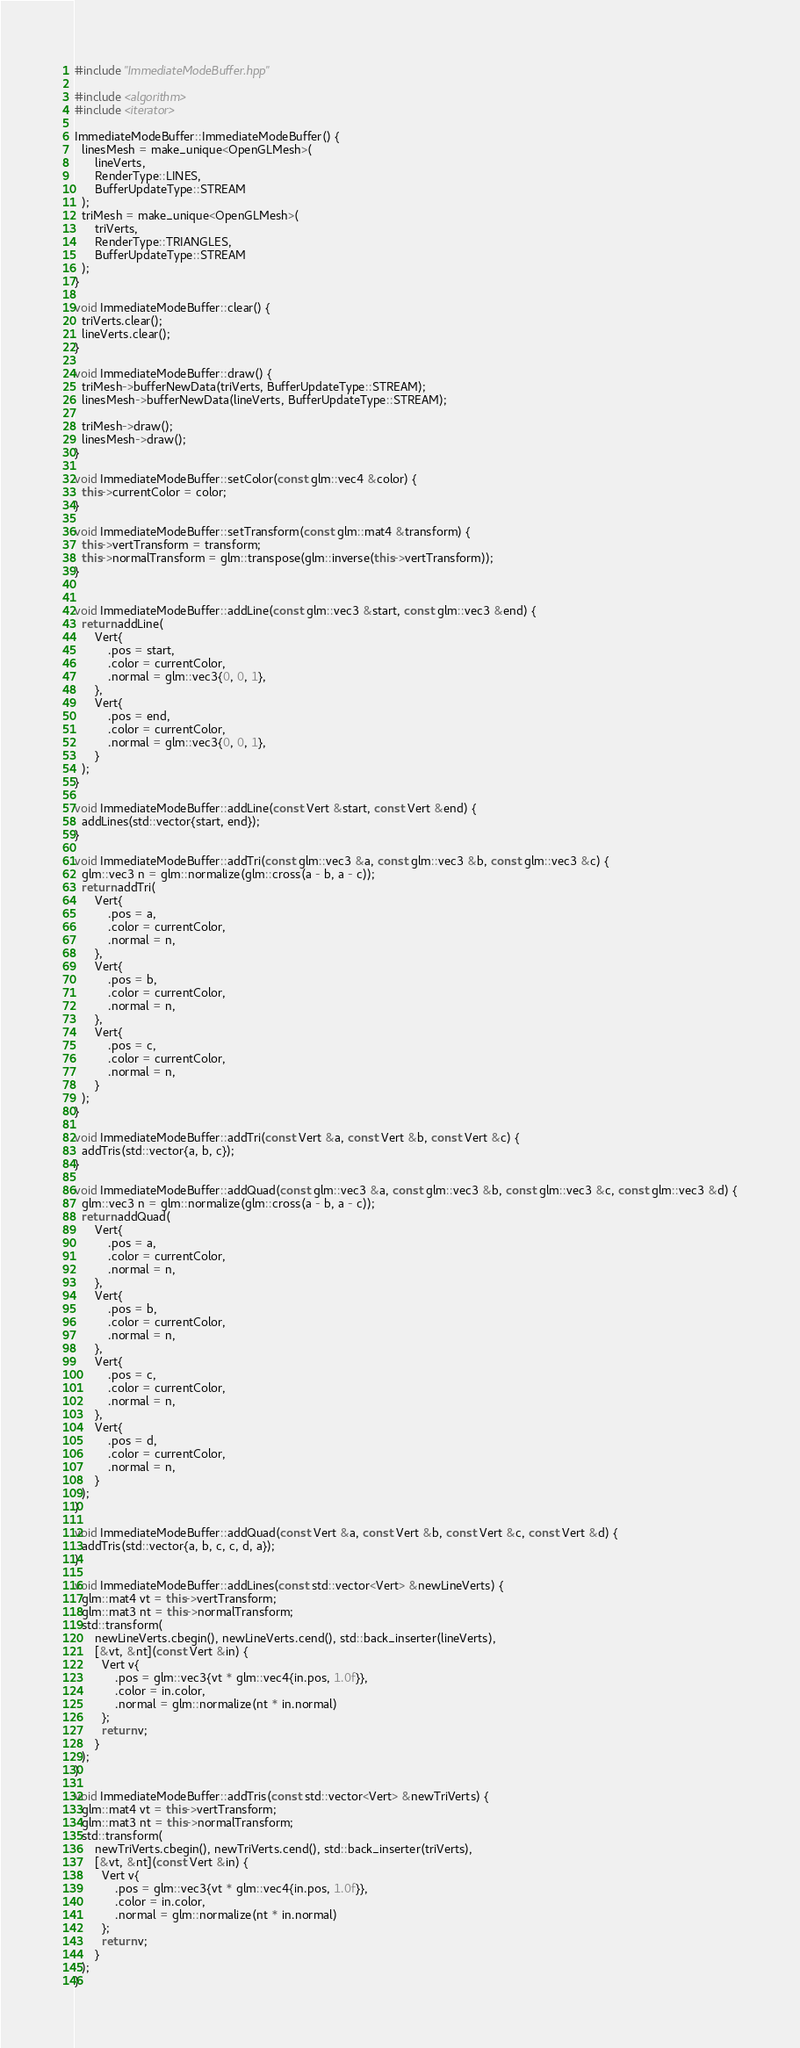<code> <loc_0><loc_0><loc_500><loc_500><_C++_>#include "ImmediateModeBuffer.hpp"

#include <algorithm>
#include <iterator>

ImmediateModeBuffer::ImmediateModeBuffer() {
  linesMesh = make_unique<OpenGLMesh>(
      lineVerts,
      RenderType::LINES,
      BufferUpdateType::STREAM
  );
  triMesh = make_unique<OpenGLMesh>(
      triVerts,
      RenderType::TRIANGLES,
      BufferUpdateType::STREAM
  );
}

void ImmediateModeBuffer::clear() {
  triVerts.clear();
  lineVerts.clear();
}

void ImmediateModeBuffer::draw() {
  triMesh->bufferNewData(triVerts, BufferUpdateType::STREAM);
  linesMesh->bufferNewData(lineVerts, BufferUpdateType::STREAM);

  triMesh->draw();
  linesMesh->draw();
}

void ImmediateModeBuffer::setColor(const glm::vec4 &color) {
  this->currentColor = color;
}

void ImmediateModeBuffer::setTransform(const glm::mat4 &transform) {
  this->vertTransform = transform;
  this->normalTransform = glm::transpose(glm::inverse(this->vertTransform));
}


void ImmediateModeBuffer::addLine(const glm::vec3 &start, const glm::vec3 &end) {
  return addLine(
      Vert{
          .pos = start,
          .color = currentColor,
          .normal = glm::vec3{0, 0, 1},
      },
      Vert{
          .pos = end,
          .color = currentColor,
          .normal = glm::vec3{0, 0, 1},
      }
  );
}

void ImmediateModeBuffer::addLine(const Vert &start, const Vert &end) {
  addLines(std::vector{start, end});
}

void ImmediateModeBuffer::addTri(const glm::vec3 &a, const glm::vec3 &b, const glm::vec3 &c) {
  glm::vec3 n = glm::normalize(glm::cross(a - b, a - c));
  return addTri(
      Vert{
          .pos = a,
          .color = currentColor,
          .normal = n,
      },
      Vert{
          .pos = b,
          .color = currentColor,
          .normal = n,
      },
      Vert{
          .pos = c,
          .color = currentColor,
          .normal = n,
      }
  );
}

void ImmediateModeBuffer::addTri(const Vert &a, const Vert &b, const Vert &c) {
  addTris(std::vector{a, b, c});
}

void ImmediateModeBuffer::addQuad(const glm::vec3 &a, const glm::vec3 &b, const glm::vec3 &c, const glm::vec3 &d) {
  glm::vec3 n = glm::normalize(glm::cross(a - b, a - c));
  return addQuad(
      Vert{
          .pos = a,
          .color = currentColor,
          .normal = n,
      },
      Vert{
          .pos = b,
          .color = currentColor,
          .normal = n,
      },
      Vert{
          .pos = c,
          .color = currentColor,
          .normal = n,
      },
      Vert{
          .pos = d,
          .color = currentColor,
          .normal = n,
      }
  );
}

void ImmediateModeBuffer::addQuad(const Vert &a, const Vert &b, const Vert &c, const Vert &d) {
  addTris(std::vector{a, b, c, c, d, a});
}

void ImmediateModeBuffer::addLines(const std::vector<Vert> &newLineVerts) {
  glm::mat4 vt = this->vertTransform;
  glm::mat3 nt = this->normalTransform;
  std::transform(
      newLineVerts.cbegin(), newLineVerts.cend(), std::back_inserter(lineVerts),
      [&vt, &nt](const Vert &in) {
        Vert v{
            .pos = glm::vec3{vt * glm::vec4{in.pos, 1.0f}},
            .color = in.color,
            .normal = glm::normalize(nt * in.normal)
        };
        return v;
      }
  );
}

void ImmediateModeBuffer::addTris(const std::vector<Vert> &newTriVerts) {
  glm::mat4 vt = this->vertTransform;
  glm::mat3 nt = this->normalTransform;
  std::transform(
      newTriVerts.cbegin(), newTriVerts.cend(), std::back_inserter(triVerts),
      [&vt, &nt](const Vert &in) {
        Vert v{
            .pos = glm::vec3{vt * glm::vec4{in.pos, 1.0f}},
            .color = in.color,
            .normal = glm::normalize(nt * in.normal)
        };
        return v;
      }
  );
}
</code> 